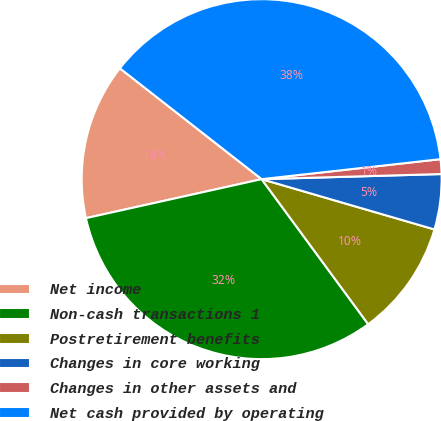<chart> <loc_0><loc_0><loc_500><loc_500><pie_chart><fcel>Net income<fcel>Non-cash transactions 1<fcel>Postretirement benefits<fcel>Changes in core working<fcel>Changes in other assets and<fcel>Net cash provided by operating<nl><fcel>14.04%<fcel>31.61%<fcel>10.41%<fcel>4.96%<fcel>1.32%<fcel>37.67%<nl></chart> 